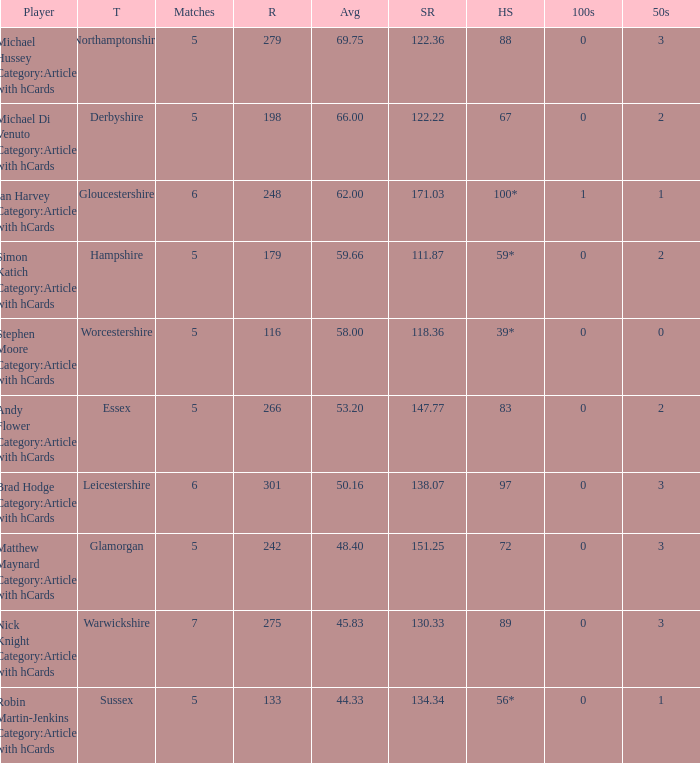If the average is 50.16, who is the player? Brad Hodge Category:Articles with hCards. 